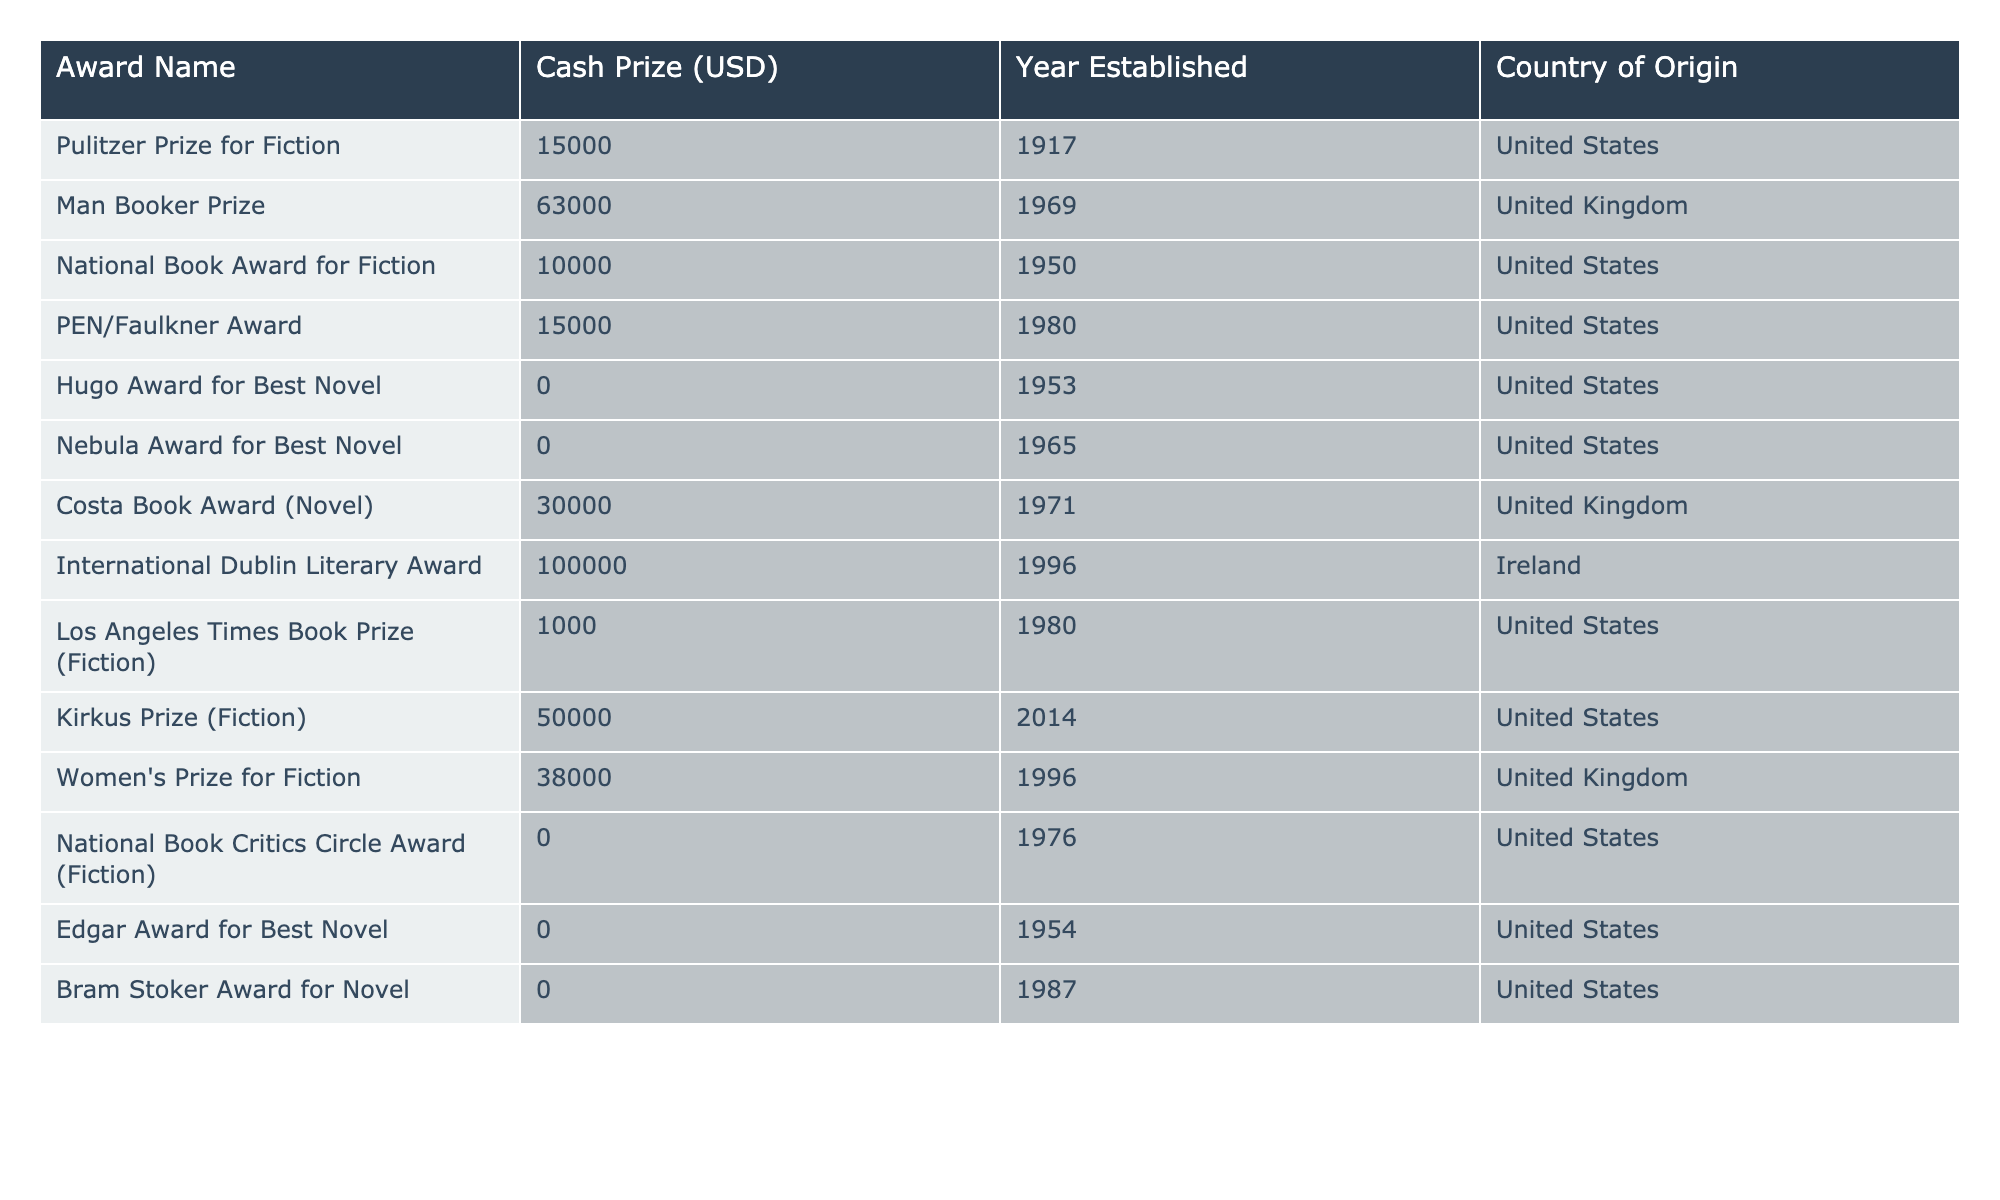What is the cash prize for the International Dublin Literary Award? The cash prize for this award is listed in the table as 100,000 USD.
Answer: 100000 Which award has the highest cash prize for fiction authors? By examining the cash prizes in the table, the International Dublin Literary Award has the highest at 100,000 USD compared to others.
Answer: International Dublin Literary Award How many awards have a cash prize of 0 USD? By counting the entries in the Cash Prize column, there are four awards (Hugo Award for Best Novel, Nebula Award for Best Novel, National Book Critics Circle Award, Edgar Award for Best Novel) listed with a cash prize of 0 USD.
Answer: 4 What is the average cash prize of the awards established in the United States? To find the average, sum the cash prizes of the six awards from the United States: 15,000 + 10,000 + 15,000 + 1,000 + 0 + 0 = 41,000 USD. Then, divide by 6, resulting in an average cash prize of approximately 6,833.33 USD.
Answer: 6833.33 Does the Kirkus Prize for Fiction have a higher cash prize than the Women's Prize for Fiction? Comparing the cash prizes, the Kirkus Prize offers 50,000 USD, while the Women's Prize offers 38,000 USD, thus confirming that the Kirkus Prize has a higher cash prize.
Answer: Yes How many of the listed awards were established before 1970? By reviewing the year established column, there are seven awards established before 1970 (Pulitzer Prize, National Book Award, PEN/Faulkner Award, Hugo Award, Nebula Award, Edgar Award, and Bram Stoker Award).
Answer: 7 Which country has the most awards listed in the table? By counting the entries from each country, the United States has six awards, while the United Kingdom has three, making the United States the country with the most awards listed.
Answer: United States What is the sum of cash prizes for all awards from the United Kingdom? The cash prizes for the awards from the United Kingdom are 63,000 + 30,000 + 38,000 = 131,000 USD, which is the total sum for these awards.
Answer: 131000 